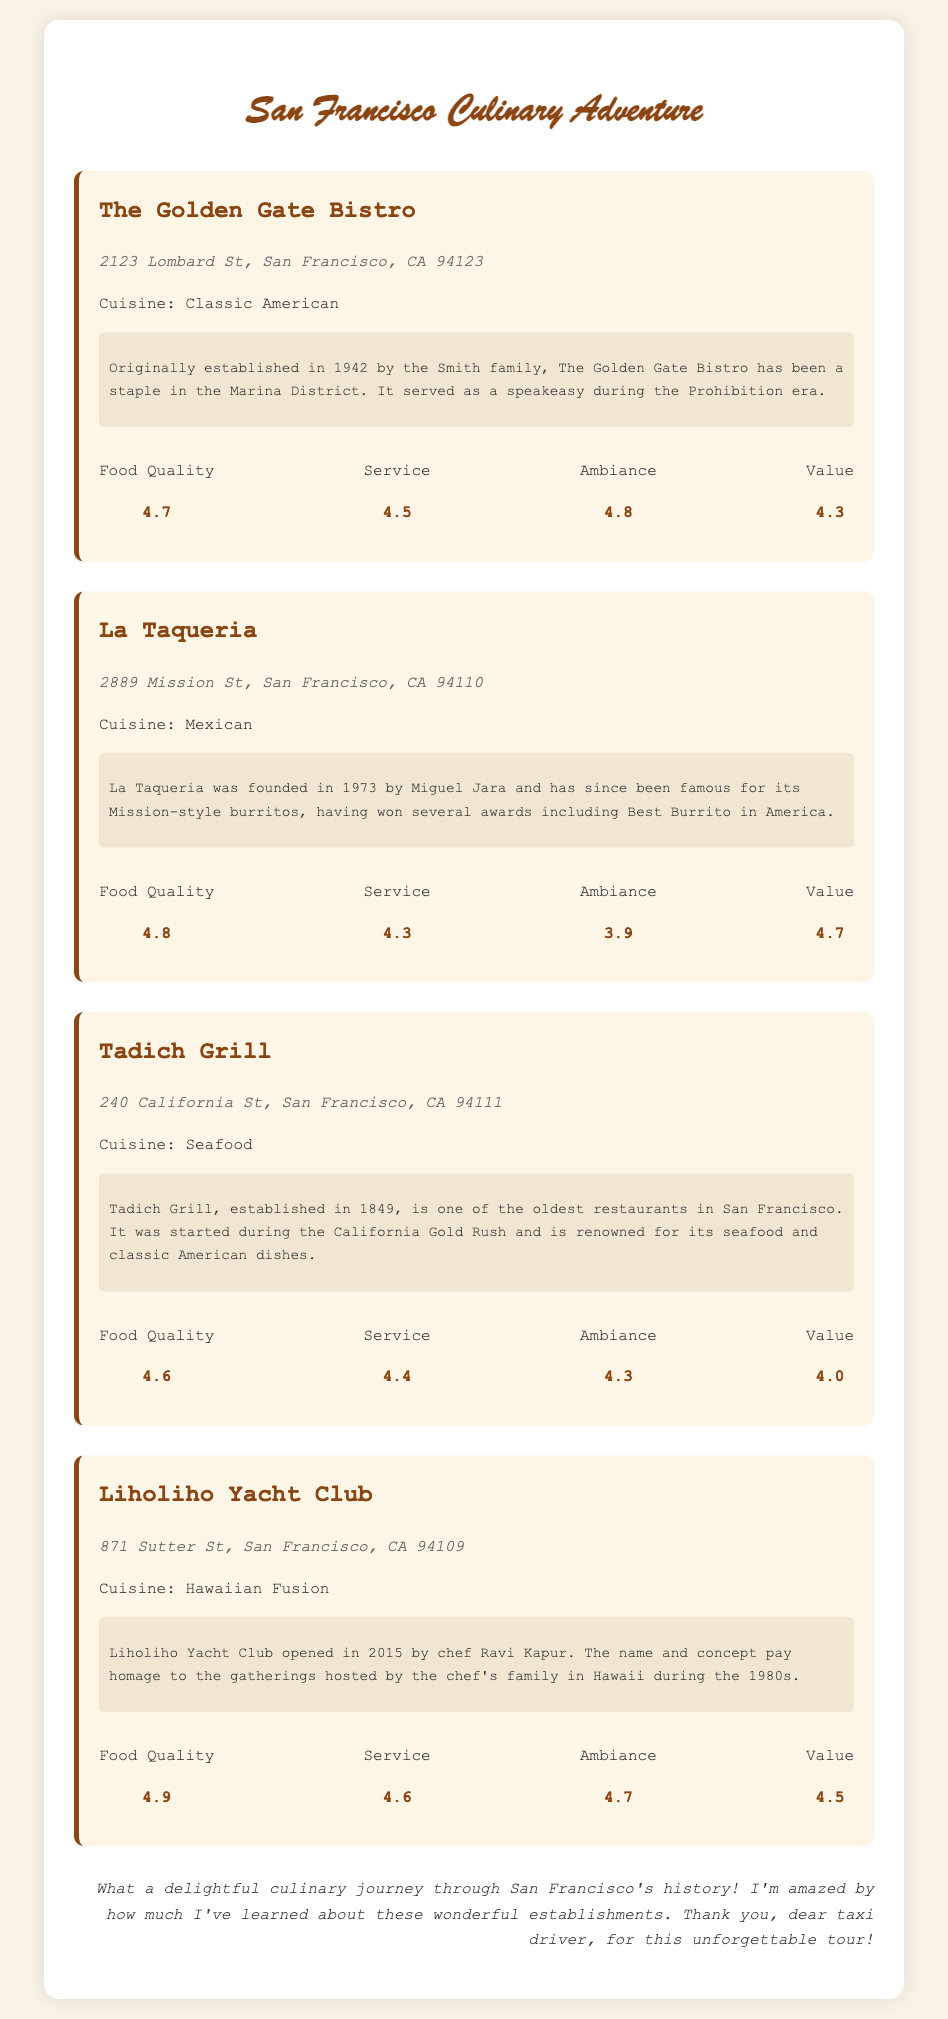what is the address of The Golden Gate Bistro? The address is specified directly in the document under the restaurant's section.
Answer: 2123 Lombard St, San Francisco, CA 94123 what year was La Taqueria founded? The founding year can be found in the historical facts section of the restaurant record.
Answer: 1973 which restaurant is the oldest in San Francisco? The document mentions the establishment date of each restaurant, indicating which one is the oldest.
Answer: Tadich Grill what cuisine type does Liholiho Yacht Club offer? The type of cuisine is provided in each restaurant description in the document.
Answer: Hawaiian Fusion what is the food quality rating of Tadich Grill? The rating is clearly stated in the ratings section of each restaurant's description.
Answer: 4.6 how many awards has La Taqueria won for its burritos? The document mentions that it has won several awards but does not specify a number, requiring reasoning about the text.
Answer: several what is the ambiance rating for La Taqueria? The ambiance rating is listed next to the restaurant's ratings details in the document.
Answer: 3.9 who established The Golden Gate Bistro? The document states that it was established by the Smith family.
Answer: Smith family 